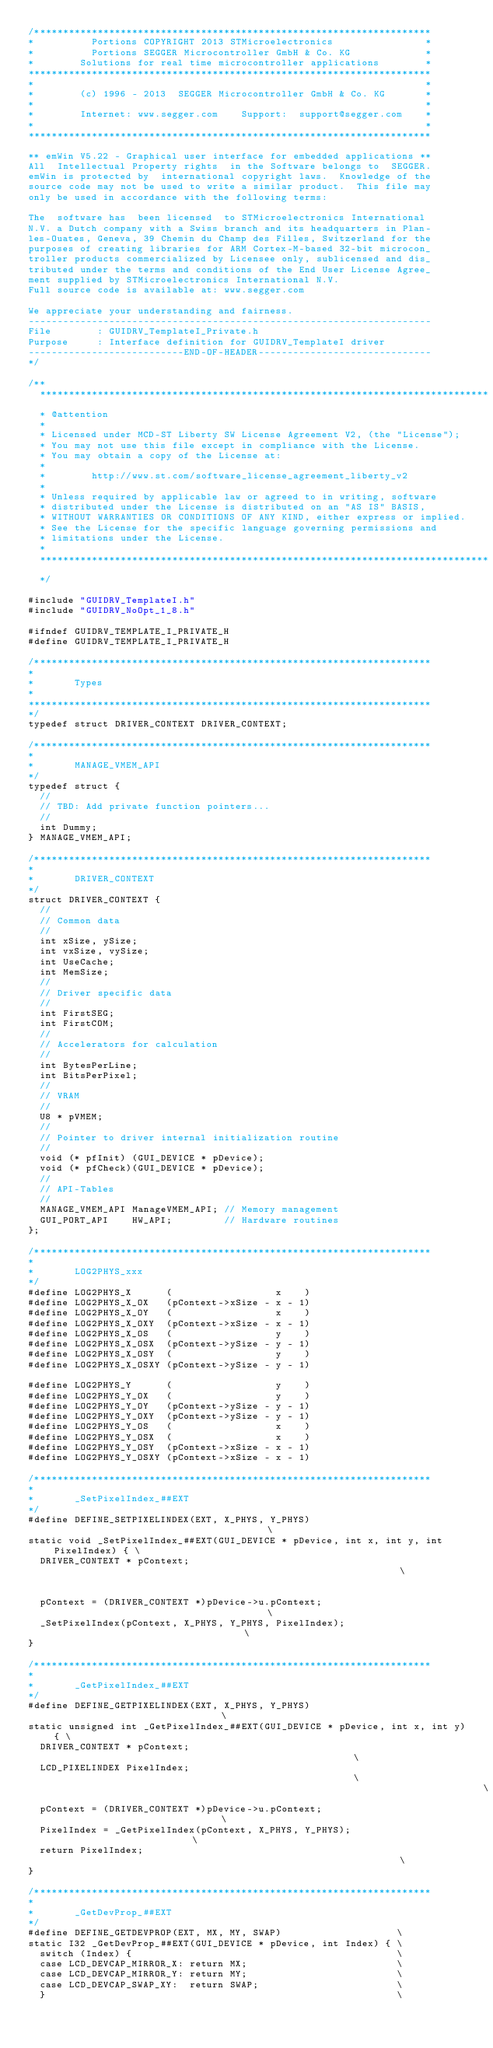Convert code to text. <code><loc_0><loc_0><loc_500><loc_500><_C_>/*********************************************************************
*          Portions COPYRIGHT 2013 STMicroelectronics                *
*          Portions SEGGER Microcontroller GmbH & Co. KG             *
*        Solutions for real time microcontroller applications        *
**********************************************************************
*                                                                    *
*        (c) 1996 - 2013  SEGGER Microcontroller GmbH & Co. KG       *
*                                                                    *
*        Internet: www.segger.com    Support:  support@segger.com    *
*                                                                    *
**********************************************************************

** emWin V5.22 - Graphical user interface for embedded applications **
All  Intellectual Property rights  in the Software belongs to  SEGGER.
emWin is protected by  international copyright laws.  Knowledge of the
source code may not be used to write a similar product.  This file may
only be used in accordance with the following terms:

The  software has  been licensed  to STMicroelectronics International
N.V. a Dutch company with a Swiss branch and its headquarters in Plan-
les-Ouates, Geneva, 39 Chemin du Champ des Filles, Switzerland for the
purposes of creating libraries for ARM Cortex-M-based 32-bit microcon_
troller products commercialized by Licensee only, sublicensed and dis_
tributed under the terms and conditions of the End User License Agree_
ment supplied by STMicroelectronics International N.V.
Full source code is available at: www.segger.com

We appreciate your understanding and fairness.
----------------------------------------------------------------------
File        : GUIDRV_TemplateI_Private.h
Purpose     : Interface definition for GUIDRV_TemplateI driver
---------------------------END-OF-HEADER------------------------------
*/

/**
  ******************************************************************************
  * @attention
  *
  * Licensed under MCD-ST Liberty SW License Agreement V2, (the "License");
  * You may not use this file except in compliance with the License.
  * You may obtain a copy of the License at:
  *
  *        http://www.st.com/software_license_agreement_liberty_v2
  *
  * Unless required by applicable law or agreed to in writing, software 
  * distributed under the License is distributed on an "AS IS" BASIS, 
  * WITHOUT WARRANTIES OR CONDITIONS OF ANY KIND, either express or implied.
  * See the License for the specific language governing permissions and
  * limitations under the License.
  *
  ******************************************************************************
  */

#include "GUIDRV_TemplateI.h"
#include "GUIDRV_NoOpt_1_8.h"

#ifndef GUIDRV_TEMPLATE_I_PRIVATE_H
#define GUIDRV_TEMPLATE_I_PRIVATE_H

/*********************************************************************
*
*       Types
*
**********************************************************************
*/
typedef struct DRIVER_CONTEXT DRIVER_CONTEXT;

/*********************************************************************
*
*       MANAGE_VMEM_API
*/
typedef struct {
  //
  // TBD: Add private function pointers...
  //
  int Dummy;
} MANAGE_VMEM_API;

/*********************************************************************
*
*       DRIVER_CONTEXT
*/
struct DRIVER_CONTEXT {
  //
  // Common data
  //
  int xSize, ySize;
  int vxSize, vySize;
  int UseCache;
  int MemSize;
  //
  // Driver specific data
  //
  int FirstSEG;
  int FirstCOM;
  //
  // Accelerators for calculation
  //
  int BytesPerLine;
  int BitsPerPixel;
  //
  // VRAM
  //
  U8 * pVMEM;
  //
  // Pointer to driver internal initialization routine
  //
  void (* pfInit) (GUI_DEVICE * pDevice);
  void (* pfCheck)(GUI_DEVICE * pDevice);
  //
  // API-Tables
  //
  MANAGE_VMEM_API ManageVMEM_API; // Memory management
  GUI_PORT_API    HW_API;         // Hardware routines
};

/*********************************************************************
*
*       LOG2PHYS_xxx
*/
#define LOG2PHYS_X      (                  x    )
#define LOG2PHYS_X_OX   (pContext->xSize - x - 1)
#define LOG2PHYS_X_OY   (                  x    )
#define LOG2PHYS_X_OXY  (pContext->xSize - x - 1)
#define LOG2PHYS_X_OS   (                  y    )
#define LOG2PHYS_X_OSX  (pContext->ySize - y - 1)
#define LOG2PHYS_X_OSY  (                  y    )
#define LOG2PHYS_X_OSXY (pContext->ySize - y - 1)

#define LOG2PHYS_Y      (                  y    )
#define LOG2PHYS_Y_OX   (                  y    )
#define LOG2PHYS_Y_OY   (pContext->ySize - y - 1)
#define LOG2PHYS_Y_OXY  (pContext->ySize - y - 1)
#define LOG2PHYS_Y_OS   (                  x    )
#define LOG2PHYS_Y_OSX  (                  x    )
#define LOG2PHYS_Y_OSY  (pContext->xSize - x - 1)
#define LOG2PHYS_Y_OSXY (pContext->xSize - x - 1)

/*********************************************************************
*
*       _SetPixelIndex_##EXT
*/
#define DEFINE_SETPIXELINDEX(EXT, X_PHYS, Y_PHYS)                                      \
static void _SetPixelIndex_##EXT(GUI_DEVICE * pDevice, int x, int y, int PixelIndex) { \
  DRIVER_CONTEXT * pContext;                                                           \
                                                                                       \
  pContext = (DRIVER_CONTEXT *)pDevice->u.pContext;                                    \
  _SetPixelIndex(pContext, X_PHYS, Y_PHYS, PixelIndex);                                \
}

/*********************************************************************
*
*       _GetPixelIndex_##EXT
*/
#define DEFINE_GETPIXELINDEX(EXT, X_PHYS, Y_PHYS)                              \
static unsigned int _GetPixelIndex_##EXT(GUI_DEVICE * pDevice, int x, int y) { \
  DRIVER_CONTEXT * pContext;                                                   \
  LCD_PIXELINDEX PixelIndex;                                                   \
                                                                               \
  pContext = (DRIVER_CONTEXT *)pDevice->u.pContext;                            \
  PixelIndex = _GetPixelIndex(pContext, X_PHYS, Y_PHYS);                       \
  return PixelIndex;                                                           \
}

/*********************************************************************
*
*       _GetDevProp_##EXT
*/
#define DEFINE_GETDEVPROP(EXT, MX, MY, SWAP)                    \
static I32 _GetDevProp_##EXT(GUI_DEVICE * pDevice, int Index) { \
  switch (Index) {                                              \
  case LCD_DEVCAP_MIRROR_X: return MX;                          \
  case LCD_DEVCAP_MIRROR_Y: return MY;                          \
  case LCD_DEVCAP_SWAP_XY:  return SWAP;                        \
  }                                                             \</code> 